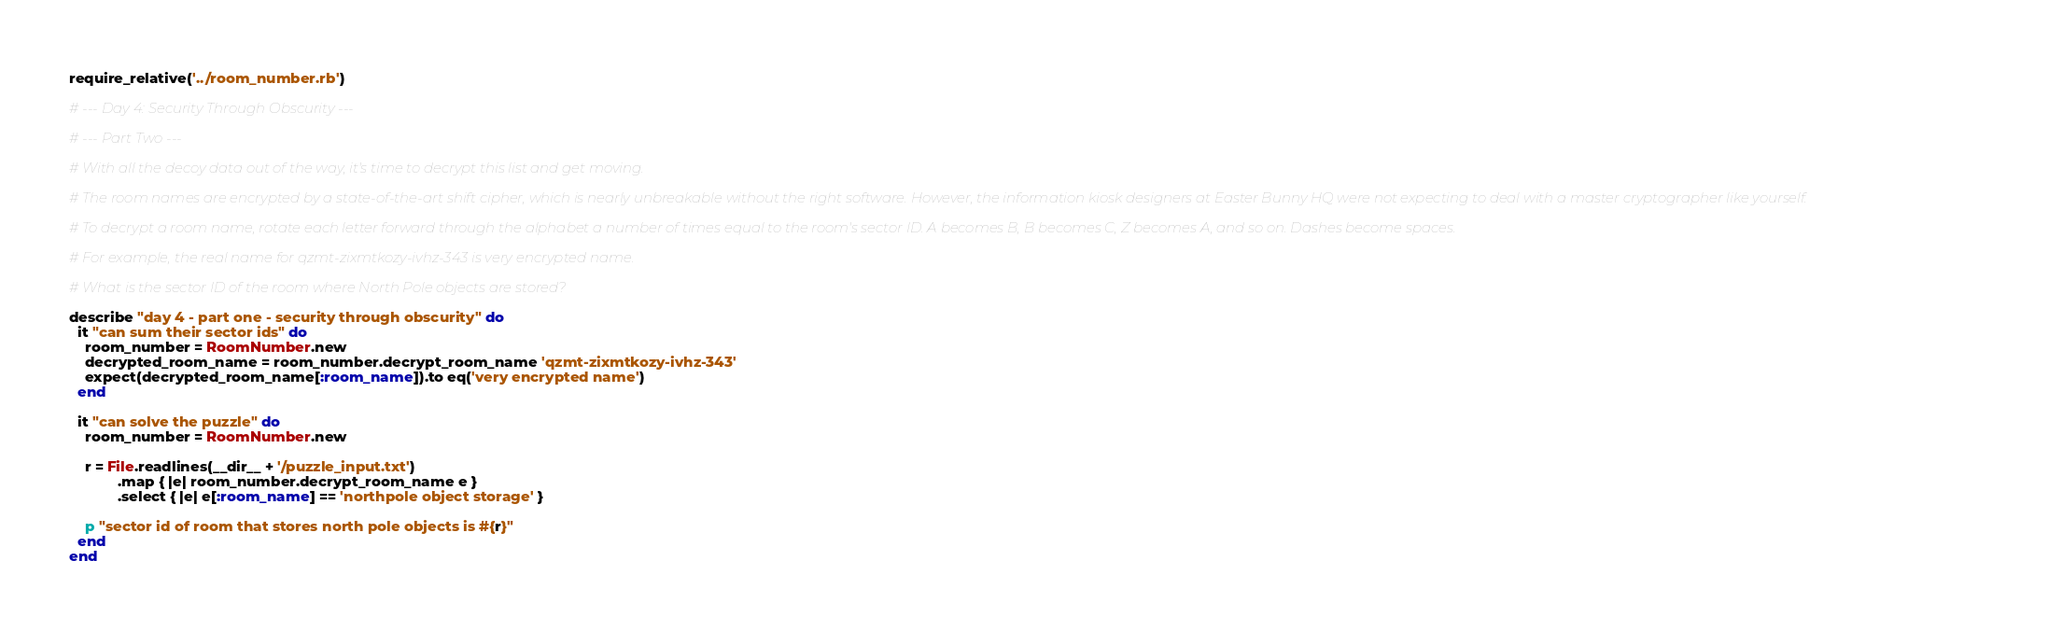<code> <loc_0><loc_0><loc_500><loc_500><_Ruby_>require_relative('../room_number.rb')

# --- Day 4: Security Through Obscurity ---

# --- Part Two ---

# With all the decoy data out of the way, it's time to decrypt this list and get moving.

# The room names are encrypted by a state-of-the-art shift cipher, which is nearly unbreakable without the right software. However, the information kiosk designers at Easter Bunny HQ were not expecting to deal with a master cryptographer like yourself.

# To decrypt a room name, rotate each letter forward through the alphabet a number of times equal to the room's sector ID. A becomes B, B becomes C, Z becomes A, and so on. Dashes become spaces.

# For example, the real name for qzmt-zixmtkozy-ivhz-343 is very encrypted name.

# What is the sector ID of the room where North Pole objects are stored?

describe "day 4 - part one - security through obscurity" do
  it "can sum their sector ids" do
    room_number = RoomNumber.new
    decrypted_room_name = room_number.decrypt_room_name 'qzmt-zixmtkozy-ivhz-343'
    expect(decrypted_room_name[:room_name]).to eq('very encrypted name')
  end

  it "can solve the puzzle" do
    room_number = RoomNumber.new

    r = File.readlines(__dir__ + '/puzzle_input.txt')
            .map { |e| room_number.decrypt_room_name e }
            .select { |e| e[:room_name] == 'northpole object storage' }

    p "sector id of room that stores north pole objects is #{r}"
  end
end</code> 